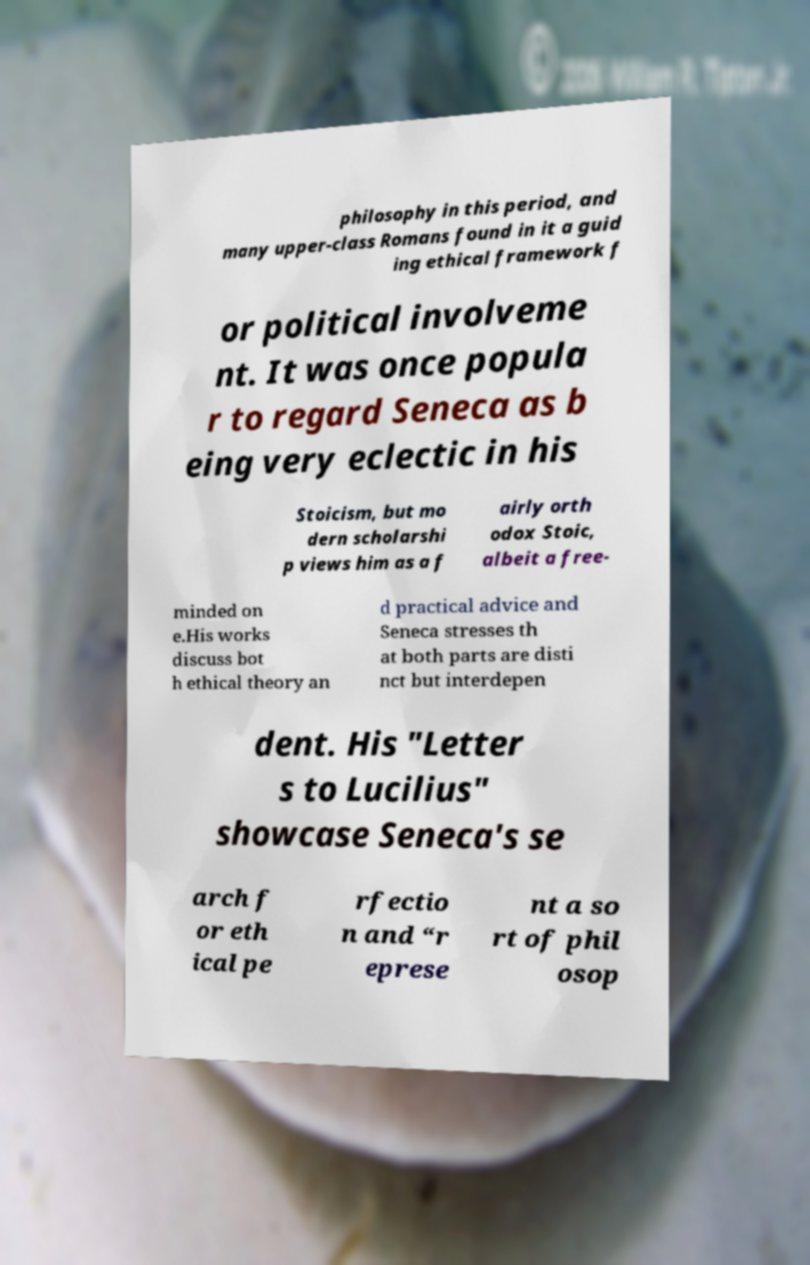Could you extract and type out the text from this image? philosophy in this period, and many upper-class Romans found in it a guid ing ethical framework f or political involveme nt. It was once popula r to regard Seneca as b eing very eclectic in his Stoicism, but mo dern scholarshi p views him as a f airly orth odox Stoic, albeit a free- minded on e.His works discuss bot h ethical theory an d practical advice and Seneca stresses th at both parts are disti nct but interdepen dent. His "Letter s to Lucilius" showcase Seneca's se arch f or eth ical pe rfectio n and “r eprese nt a so rt of phil osop 